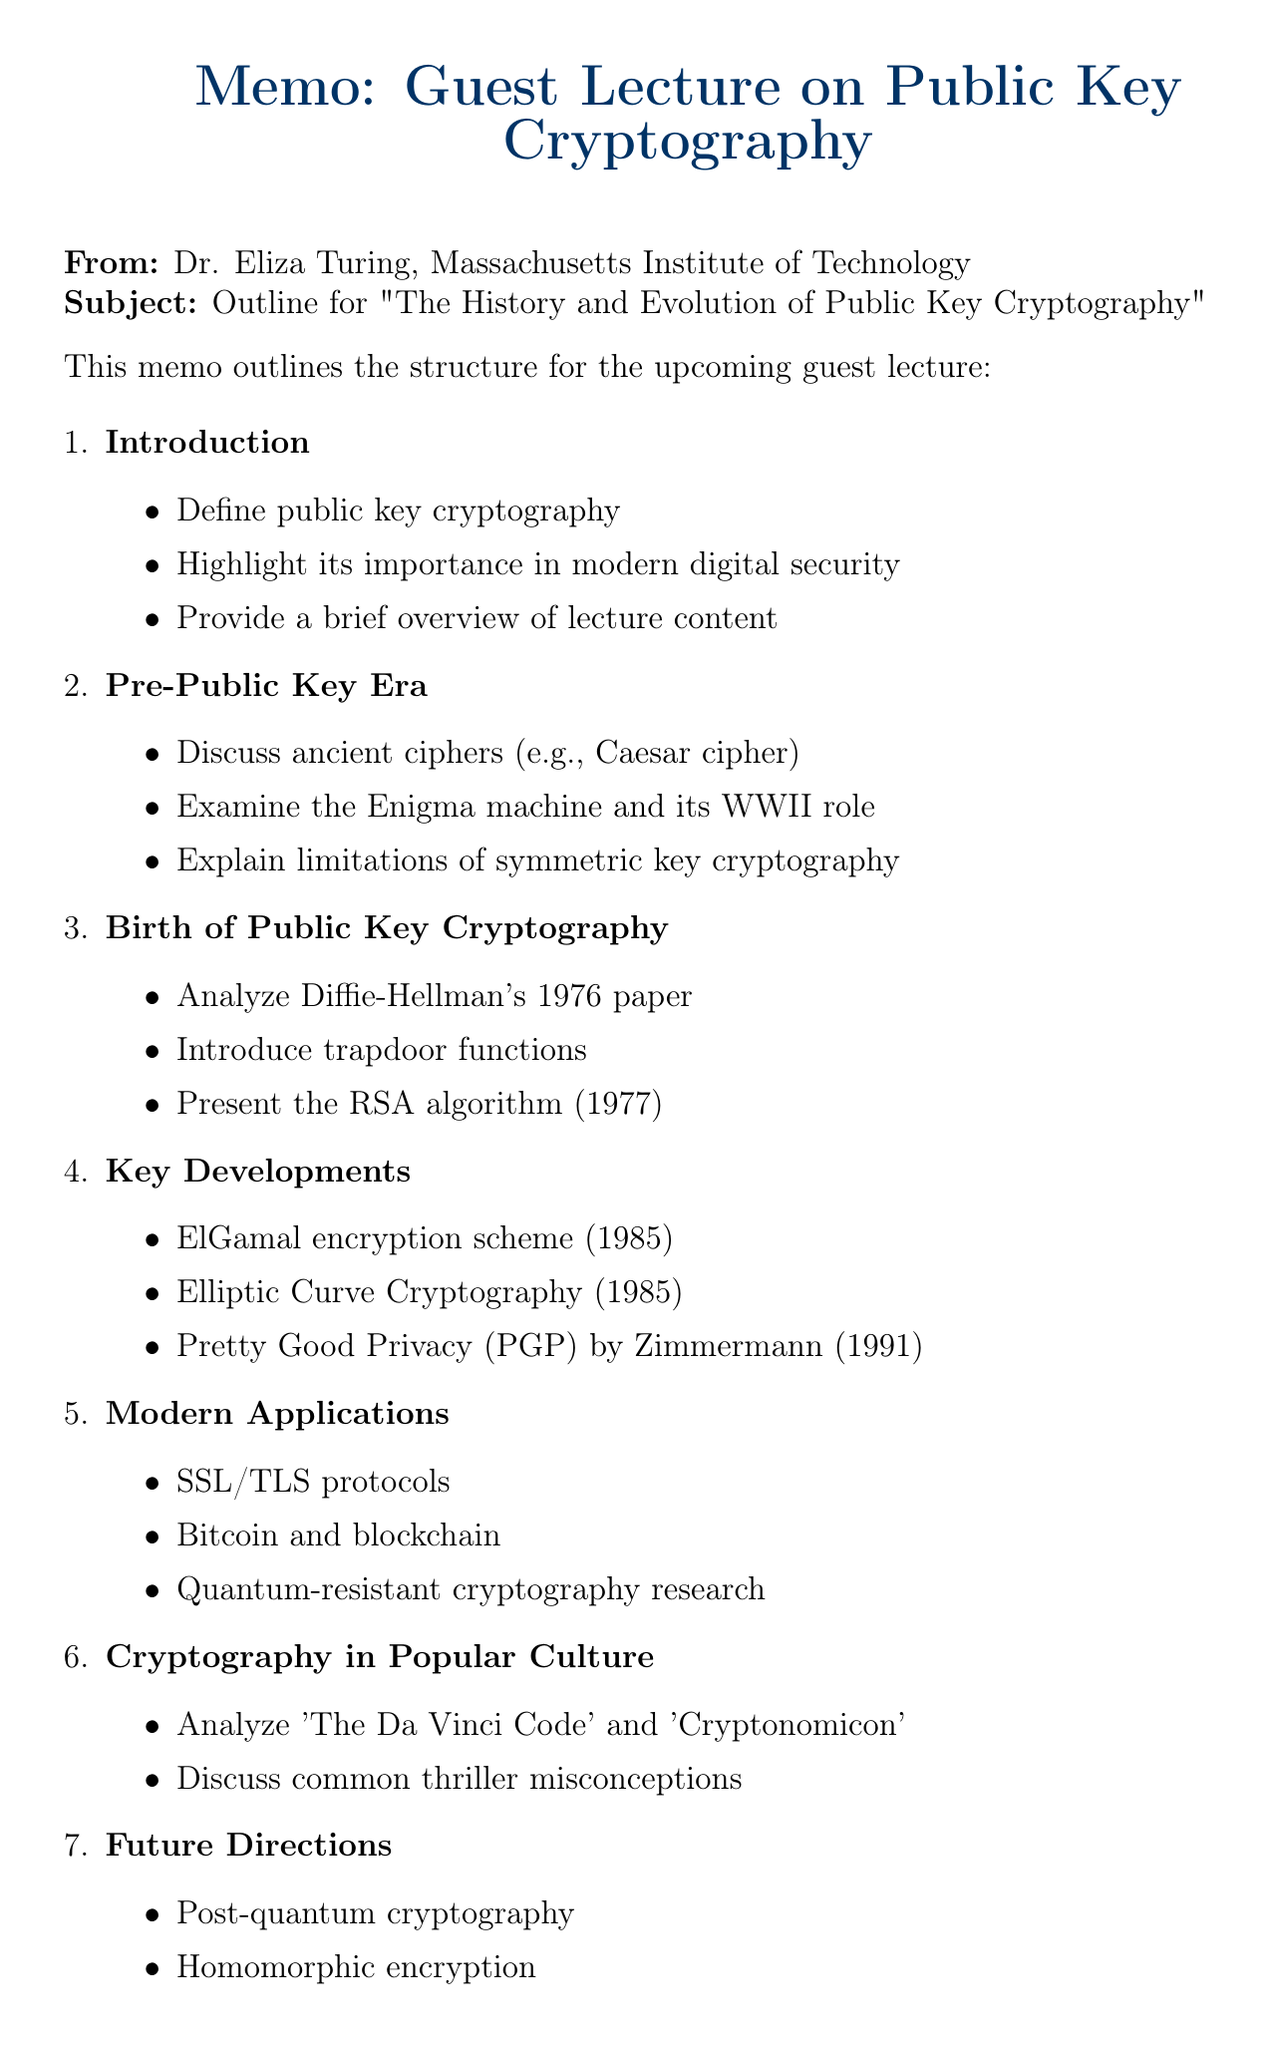What is the title of the lecture? The title of the lecture is explicitly stated at the top of the document.
Answer: The History and Evolution of Public Key Cryptography Who is the lecturer? The name of the lecturer is mentioned in the memo.
Answer: Dr. Eliza Turing What year was the RSA algorithm introduced? The RSA algorithm was introduced in a specific year mentioned in the document.
Answer: 1977 Name one application of public key cryptography mentioned in the document. The applications of public key cryptography are listed in a section, and one of them is provided.
Answer: SSL/TLS protocols for secure web browsing Which book by Simon Singh is recommended in the readings? The document lists recommended readings, including one by Simon Singh.
Answer: The Code Book What mathematical concept is related to elliptic curves? One of the relevant mathematical concepts mentioned in the document pertains to elliptic curves.
Answer: Elliptic curves Which film featuring cryptography was released in 2014? The document lists films that reference cryptography, including their release years.
Answer: The Imitation Game What major shift is mentioned in the section on future directions? The future directions section mentions a significant focus for the upcoming study in cryptography.
Answer: Post-quantum cryptography 